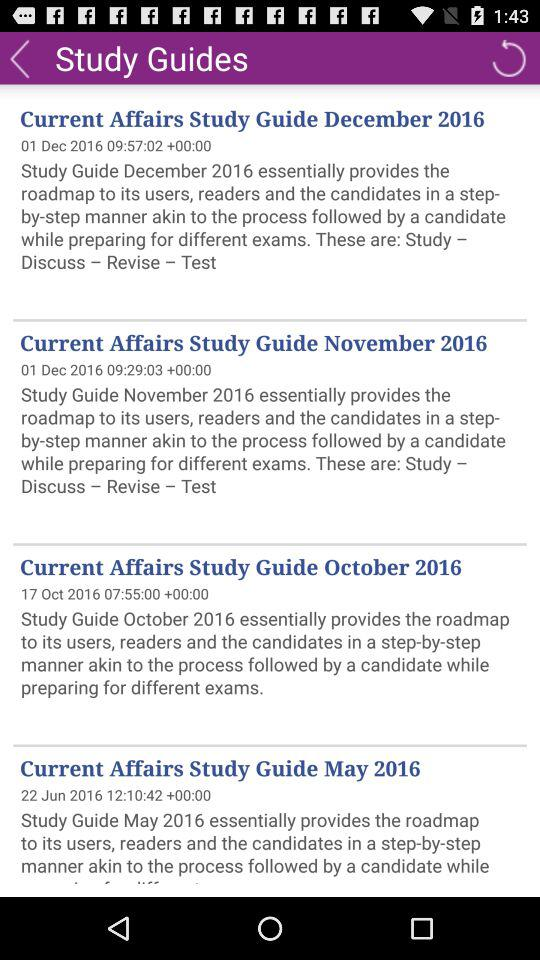Which current affair was updated on 22 June 2016? The current affair that was updated on 22 June 2016 is "Current Affairs Study Guide May 2016". 